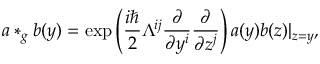Convert formula to latex. <formula><loc_0><loc_0><loc_500><loc_500>a * _ { g } b ( y ) = \exp \left ( \frac { i } 2 \Lambda ^ { i j } \frac { \partial } \partial y ^ { i } } \frac { \partial } \partial z ^ { j } } \right ) a ( y ) b ( z ) | _ { z = y } ,</formula> 